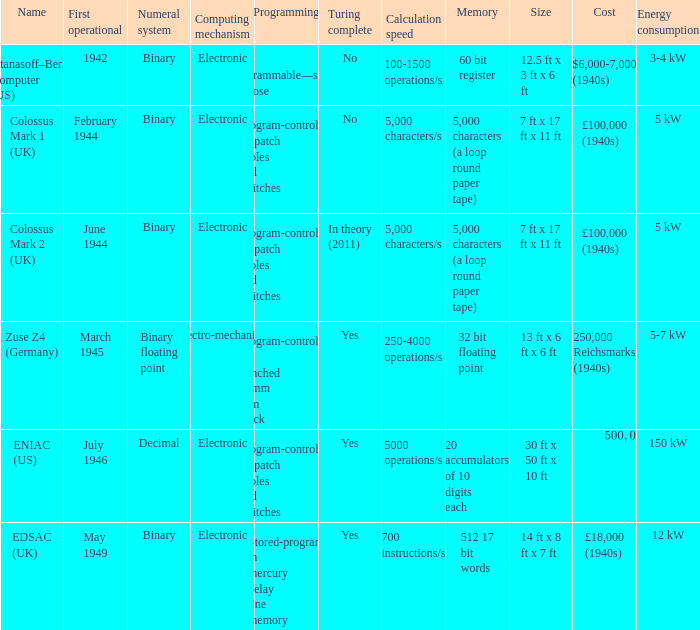What's the name with first operational being march 1945 Zuse Z4 (Germany). 